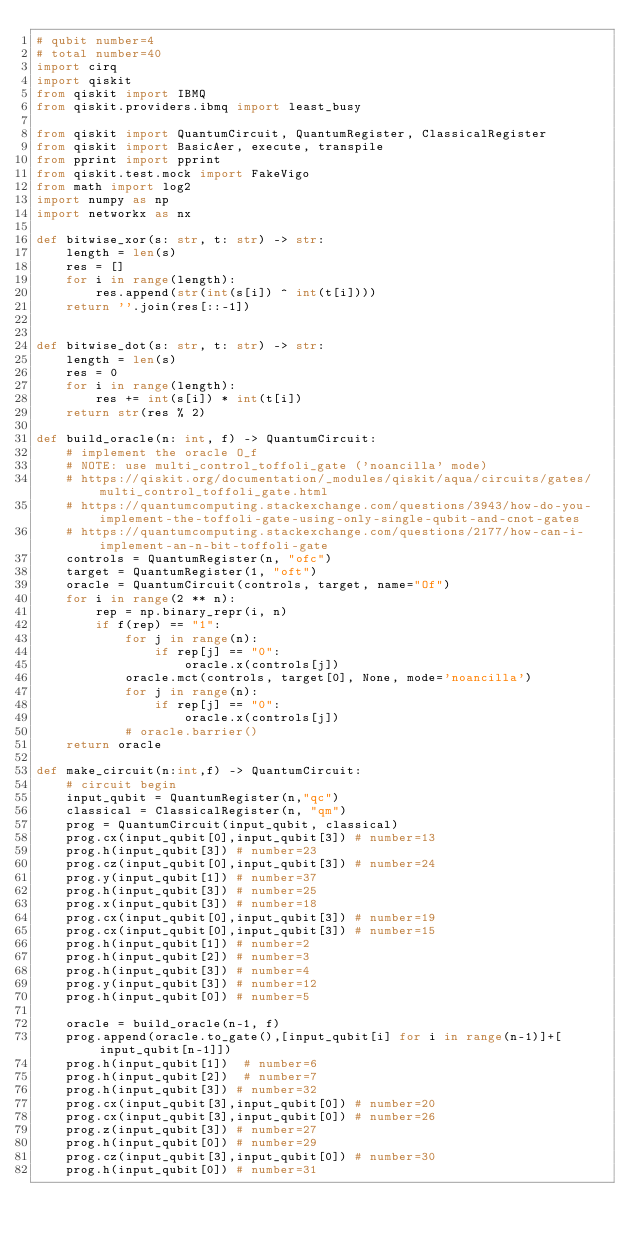<code> <loc_0><loc_0><loc_500><loc_500><_Python_># qubit number=4
# total number=40
import cirq
import qiskit
from qiskit import IBMQ
from qiskit.providers.ibmq import least_busy

from qiskit import QuantumCircuit, QuantumRegister, ClassicalRegister
from qiskit import BasicAer, execute, transpile
from pprint import pprint
from qiskit.test.mock import FakeVigo
from math import log2
import numpy as np
import networkx as nx

def bitwise_xor(s: str, t: str) -> str:
    length = len(s)
    res = []
    for i in range(length):
        res.append(str(int(s[i]) ^ int(t[i])))
    return ''.join(res[::-1])


def bitwise_dot(s: str, t: str) -> str:
    length = len(s)
    res = 0
    for i in range(length):
        res += int(s[i]) * int(t[i])
    return str(res % 2)

def build_oracle(n: int, f) -> QuantumCircuit:
    # implement the oracle O_f
    # NOTE: use multi_control_toffoli_gate ('noancilla' mode)
    # https://qiskit.org/documentation/_modules/qiskit/aqua/circuits/gates/multi_control_toffoli_gate.html
    # https://quantumcomputing.stackexchange.com/questions/3943/how-do-you-implement-the-toffoli-gate-using-only-single-qubit-and-cnot-gates
    # https://quantumcomputing.stackexchange.com/questions/2177/how-can-i-implement-an-n-bit-toffoli-gate
    controls = QuantumRegister(n, "ofc")
    target = QuantumRegister(1, "oft")
    oracle = QuantumCircuit(controls, target, name="Of")
    for i in range(2 ** n):
        rep = np.binary_repr(i, n)
        if f(rep) == "1":
            for j in range(n):
                if rep[j] == "0":
                    oracle.x(controls[j])
            oracle.mct(controls, target[0], None, mode='noancilla')
            for j in range(n):
                if rep[j] == "0":
                    oracle.x(controls[j])
            # oracle.barrier()
    return oracle

def make_circuit(n:int,f) -> QuantumCircuit:
    # circuit begin
    input_qubit = QuantumRegister(n,"qc")
    classical = ClassicalRegister(n, "qm")
    prog = QuantumCircuit(input_qubit, classical)
    prog.cx(input_qubit[0],input_qubit[3]) # number=13
    prog.h(input_qubit[3]) # number=23
    prog.cz(input_qubit[0],input_qubit[3]) # number=24
    prog.y(input_qubit[1]) # number=37
    prog.h(input_qubit[3]) # number=25
    prog.x(input_qubit[3]) # number=18
    prog.cx(input_qubit[0],input_qubit[3]) # number=19
    prog.cx(input_qubit[0],input_qubit[3]) # number=15
    prog.h(input_qubit[1]) # number=2
    prog.h(input_qubit[2]) # number=3
    prog.h(input_qubit[3]) # number=4
    prog.y(input_qubit[3]) # number=12
    prog.h(input_qubit[0]) # number=5

    oracle = build_oracle(n-1, f)
    prog.append(oracle.to_gate(),[input_qubit[i] for i in range(n-1)]+[input_qubit[n-1]])
    prog.h(input_qubit[1])  # number=6
    prog.h(input_qubit[2])  # number=7
    prog.h(input_qubit[3]) # number=32
    prog.cx(input_qubit[3],input_qubit[0]) # number=20
    prog.cx(input_qubit[3],input_qubit[0]) # number=26
    prog.z(input_qubit[3]) # number=27
    prog.h(input_qubit[0]) # number=29
    prog.cz(input_qubit[3],input_qubit[0]) # number=30
    prog.h(input_qubit[0]) # number=31</code> 